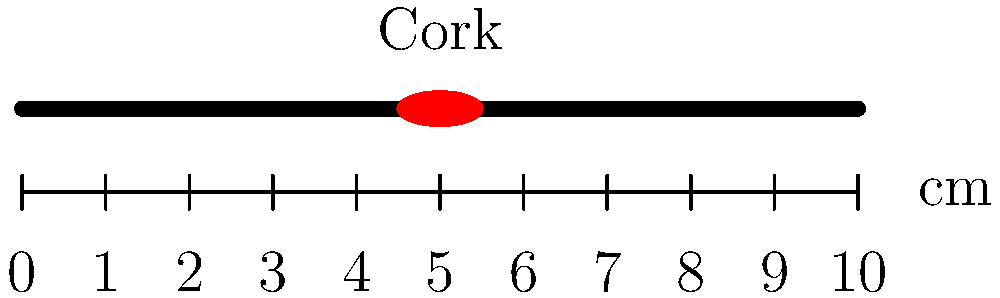In the diagram above, a baseball bat is shown with an illegal modification. What is the nature of this modification, and at approximately what position along the bat's length is it located? To answer this question, let's analyze the diagram step-by-step:

1. The diagram shows a baseball bat represented by a horizontal line.
2. There is a red elliptical shape inside the bat, labeled "Cork."
3. A ruler is provided below the bat, measuring from 0 to 10 cm.

Analyzing these elements:

1. The red elliptical shape inside the bat represents an illegal modification.
2. This modification is labeled "Cork," indicating that the bat has been illegally filled with cork.
3. Cork-filling is a known illegal modification in baseball, used to make the bat lighter and increase swing speed.
4. The cork is located at approximately the midpoint of the bat.
5. Using the ruler provided, we can estimate that the cork is positioned at about 5 cm along the 10 cm length of the bat.

Therefore, the illegal modification is cork-filling, located at approximately the midpoint (5 cm) of the bat's length.
Answer: Cork-filling at 5 cm (midpoint) 